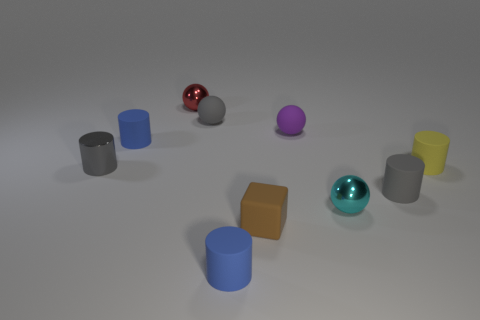Subtract all yellow cylinders. How many cylinders are left? 4 Subtract all small gray matte cylinders. How many cylinders are left? 4 Subtract all cyan cylinders. Subtract all green balls. How many cylinders are left? 5 Subtract all blocks. How many objects are left? 9 Add 5 metal things. How many metal things exist? 8 Subtract 0 blue cubes. How many objects are left? 10 Subtract all blue objects. Subtract all small purple matte balls. How many objects are left? 7 Add 6 gray cylinders. How many gray cylinders are left? 8 